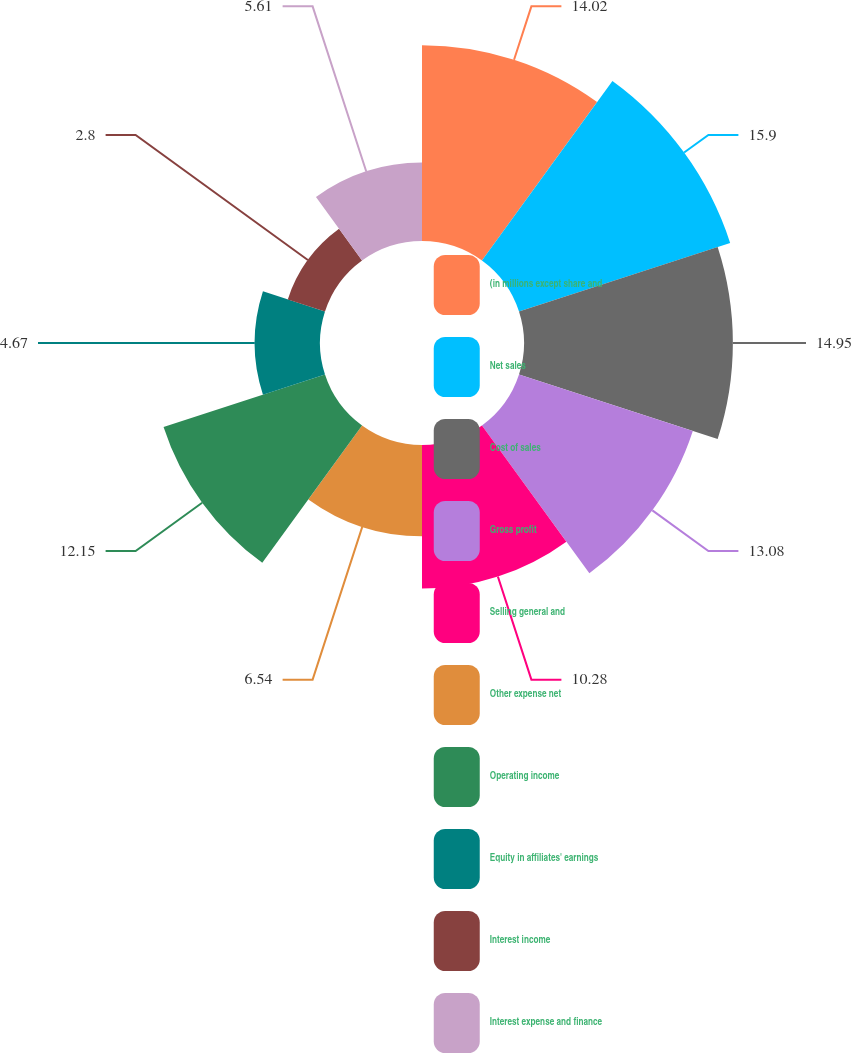Convert chart to OTSL. <chart><loc_0><loc_0><loc_500><loc_500><pie_chart><fcel>(in millions except share and<fcel>Net sales<fcel>Cost of sales<fcel>Gross profit<fcel>Selling general and<fcel>Other expense net<fcel>Operating income<fcel>Equity in affiliates' earnings<fcel>Interest income<fcel>Interest expense and finance<nl><fcel>14.02%<fcel>15.89%<fcel>14.95%<fcel>13.08%<fcel>10.28%<fcel>6.54%<fcel>12.15%<fcel>4.67%<fcel>2.8%<fcel>5.61%<nl></chart> 